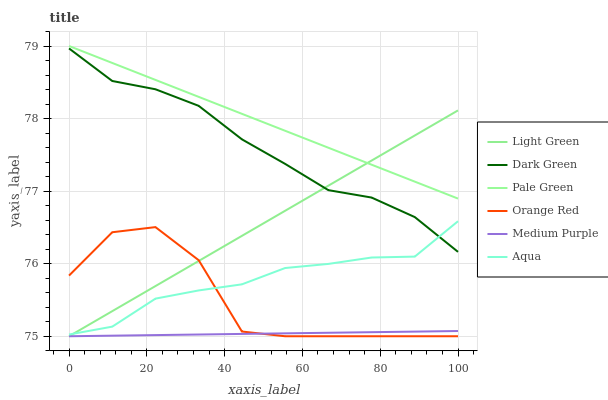Does Medium Purple have the minimum area under the curve?
Answer yes or no. Yes. Does Pale Green have the maximum area under the curve?
Answer yes or no. Yes. Does Pale Green have the minimum area under the curve?
Answer yes or no. No. Does Medium Purple have the maximum area under the curve?
Answer yes or no. No. Is Medium Purple the smoothest?
Answer yes or no. Yes. Is Orange Red the roughest?
Answer yes or no. Yes. Is Pale Green the smoothest?
Answer yes or no. No. Is Pale Green the roughest?
Answer yes or no. No. Does Medium Purple have the lowest value?
Answer yes or no. Yes. Does Pale Green have the lowest value?
Answer yes or no. No. Does Pale Green have the highest value?
Answer yes or no. Yes. Does Medium Purple have the highest value?
Answer yes or no. No. Is Medium Purple less than Aqua?
Answer yes or no. Yes. Is Pale Green greater than Dark Green?
Answer yes or no. Yes. Does Light Green intersect Dark Green?
Answer yes or no. Yes. Is Light Green less than Dark Green?
Answer yes or no. No. Is Light Green greater than Dark Green?
Answer yes or no. No. Does Medium Purple intersect Aqua?
Answer yes or no. No. 